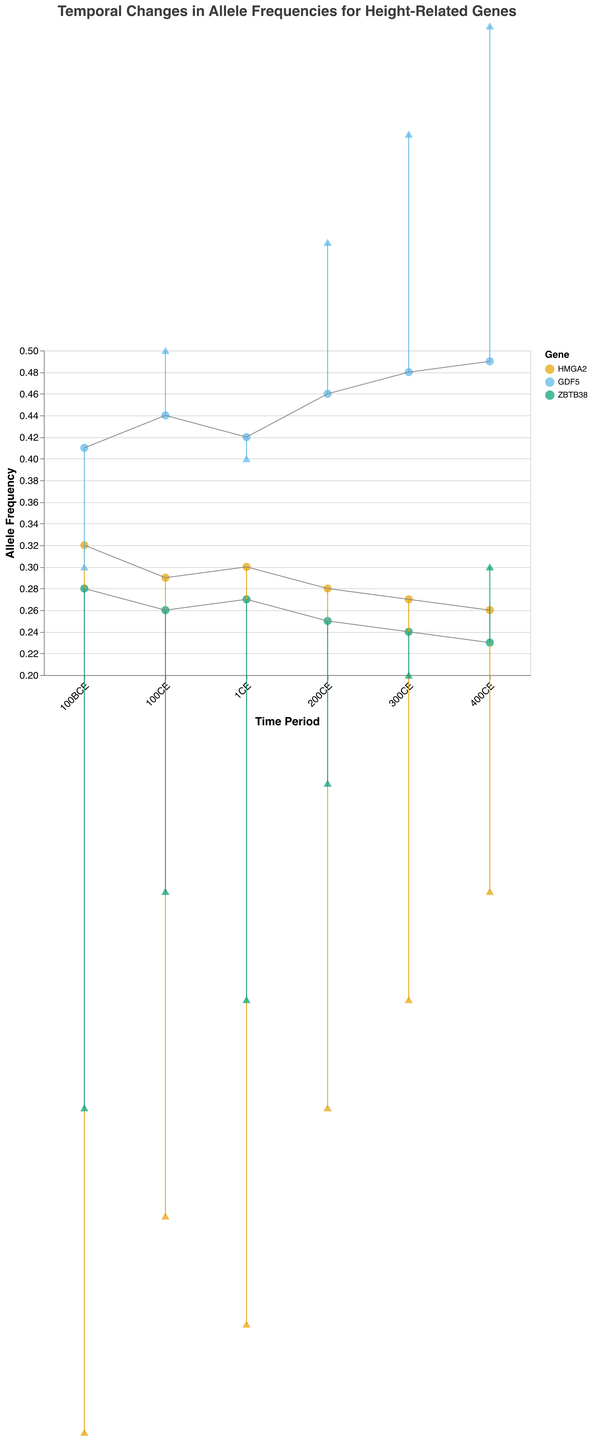What is the title of the figure? The title of the figure is located at the top and it reads: "Temporal Changes in Allele Frequencies for Height-Related Genes".
Answer: Temporal Changes in Allele Frequencies for Height-Related Genes What are the three height-related genes displayed in the figure? The legend on the right side of the figure displays the genes with their respective colors. The three genes are HMGA2, GDF5, and ZBTB38.
Answer: HMGA2, GDF5, ZBTB38 Which gene shows the highest allele frequency during the time period 400CE? The highest allele frequency can be identified by looking at the y-axis value of the data points for 400CE. GDF5 has the highest allele frequency with a value of 0.49.
Answer: GDF5 How did the allele frequency of the HMGA2 gene change from 100BCE to 400CE? To find the change, we compare the allele frequencies of HMGA2 in 100BCE (0.32) and 400CE (0.26). The difference is 0.32 - 0.26 = 0.06, indicating a decrease.
Answer: The allele frequency of HMGA2 decreased by 0.06 What was the average height change associated with the GDF5 gene in the 200CE time period? The height change associated with GDF5 in the 200CE time period can be seen from the y2-axis values, which is 0.6.
Answer: 0.6 Which gene has shown a consistent decrease in allele frequency over the time periods? By following the trend lines of each gene from 100BCE to 400CE, we observe that the ZBTB38 gene shows a consistent decrease in allele frequency.
Answer: ZBTB38 What is the difference in average height change between the GDF5 gene and the ZBTB38 gene during the time period 300CE? The average height change for the GDF5 gene during 300CE is 0.7, and for ZBTB38 it is 0.2. The difference is 0.7 - 0.2 = 0.5.
Answer: 0.5 During which time period did the HMGA2 gene show the least allele frequency, and what was that frequency? By inspecting the y-axis values for the HMGA2 gene across different time periods, we find that the least allele frequency occurs in 400CE with a value of 0.26.
Answer: 400CE, 0.26 What is the trend in average height change for the GDF5 gene over the given time periods? The average height change for GDF5 increases steadily from 0.3 in 100BCE to 0.8 in 400CE, indicating a positive trend over time.
Answer: Increasing Can you identify a time period when all three genes experienced a decrease in allele frequency? By looking at the changes in allele frequencies (y-axis values) between consecutive time periods, we observe that between 100BCE and 1CE, all three genes (HMGA2, GDF5, ZBTB38) experienced a decrease in allele frequency.
Answer: Between 100BCE and 1CE 